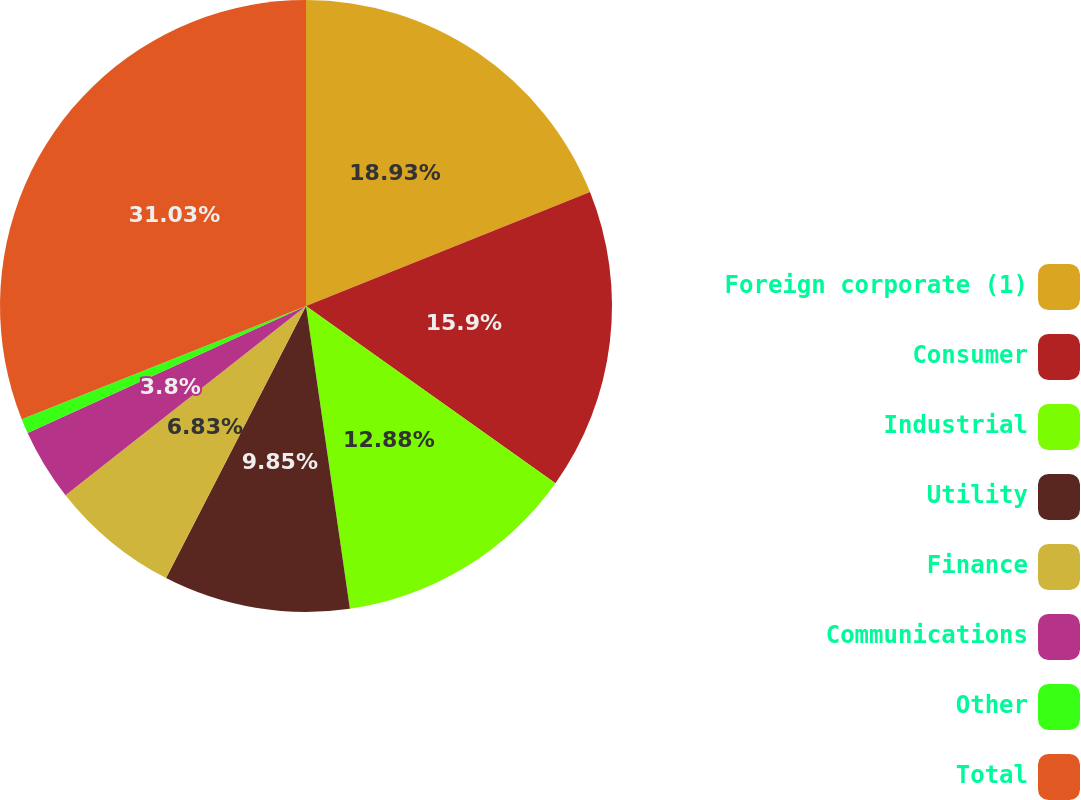Convert chart. <chart><loc_0><loc_0><loc_500><loc_500><pie_chart><fcel>Foreign corporate (1)<fcel>Consumer<fcel>Industrial<fcel>Utility<fcel>Finance<fcel>Communications<fcel>Other<fcel>Total<nl><fcel>18.93%<fcel>15.9%<fcel>12.88%<fcel>9.85%<fcel>6.83%<fcel>3.8%<fcel>0.78%<fcel>31.03%<nl></chart> 